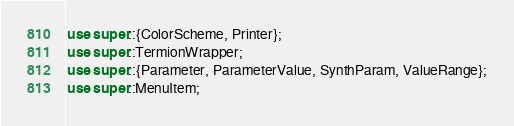<code> <loc_0><loc_0><loc_500><loc_500><_Rust_>use super::{ColorScheme, Printer};
use super::TermionWrapper;
use super::{Parameter, ParameterValue, SynthParam, ValueRange};
use super::MenuItem;</code> 